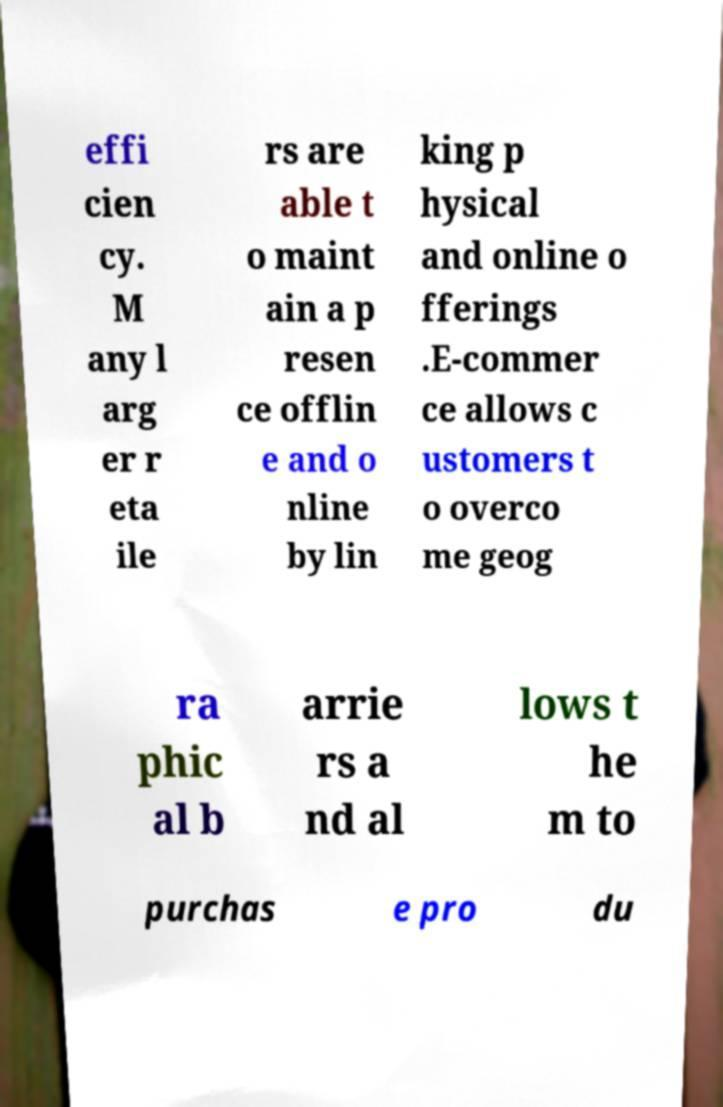Please identify and transcribe the text found in this image. effi cien cy. M any l arg er r eta ile rs are able t o maint ain a p resen ce offlin e and o nline by lin king p hysical and online o fferings .E-commer ce allows c ustomers t o overco me geog ra phic al b arrie rs a nd al lows t he m to purchas e pro du 